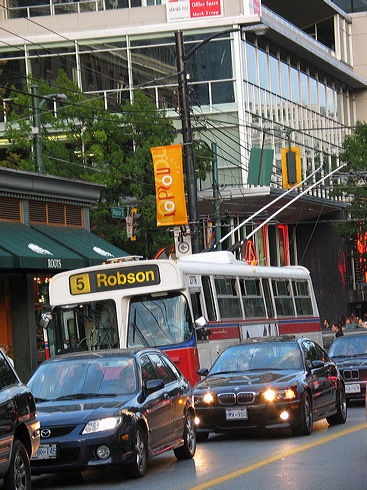Describe the objects in this image and their specific colors. I can see bus in tan, black, gray, darkgray, and lightgray tones, car in tan, black, and gray tones, car in tan, black, gray, and darkgray tones, car in tan, black, gray, maroon, and darkgray tones, and car in tan, gray, and black tones in this image. 